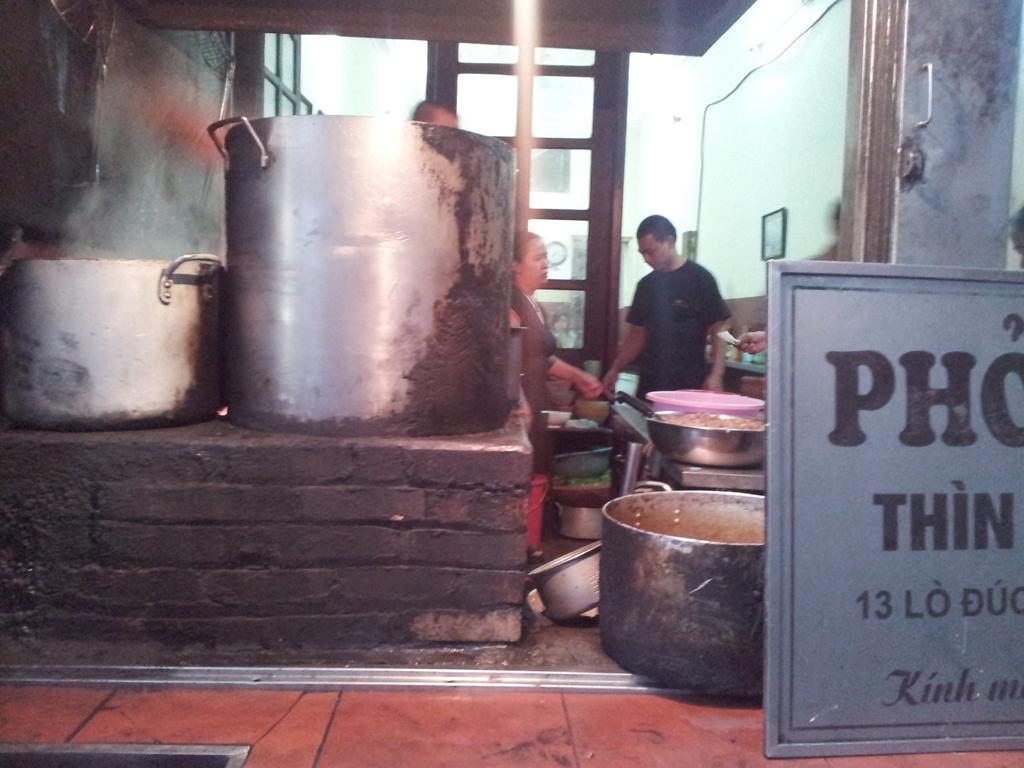Describe this image in one or two sentences. In the background we can see a clock on the wall. On the right side of the picture we can see the people, frame, few containers and the food. We can see a board and a handle. On the left side of the picture we can see the containers on the brick wall, doors. In this picture we can see few objects. At the bottom portion of the picture we can see the floor. 